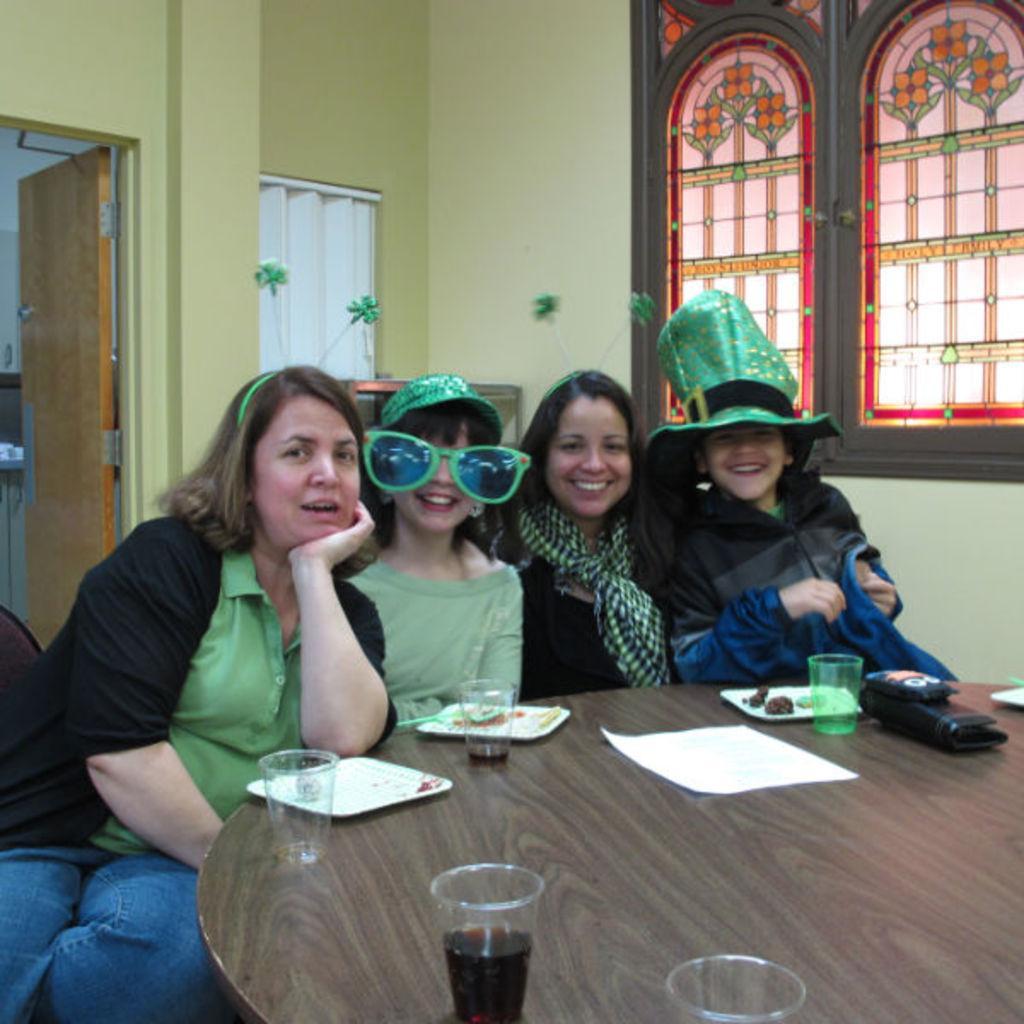Describe this image in one or two sentences. This is inside view picture of a house. On the the background we can see a wall, window and a door. This picture is mainly highlighted with four persons sitting on a chair in front of a table and we can see drinking glasses , plates and some food on the table. This is a purse and a mobile. 